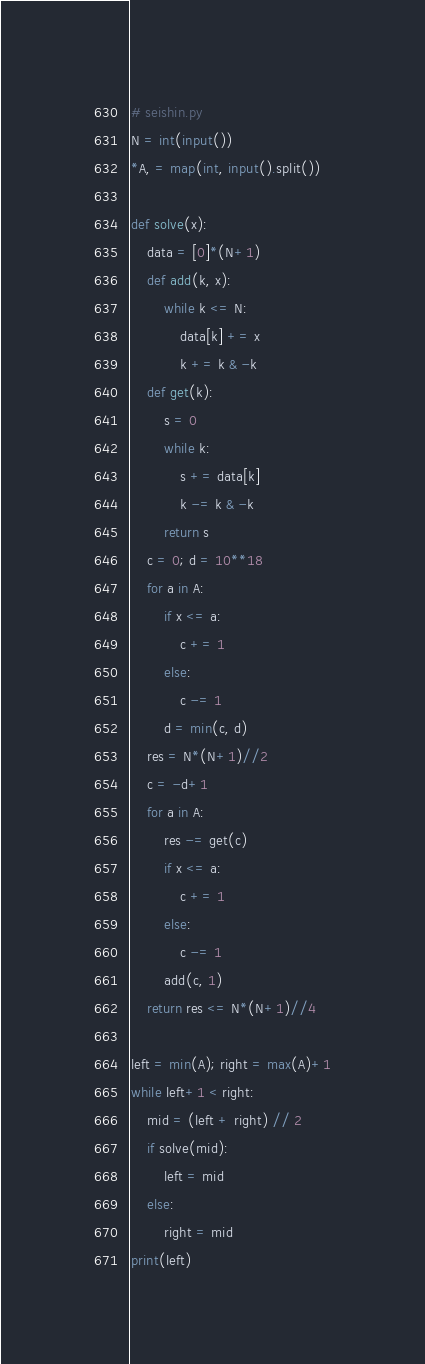Convert code to text. <code><loc_0><loc_0><loc_500><loc_500><_Python_># seishin.py
N = int(input())
*A, = map(int, input().split())

def solve(x):
    data = [0]*(N+1)
    def add(k, x):
        while k <= N:
            data[k] += x
            k += k & -k
    def get(k):
        s = 0
        while k:
            s += data[k]
            k -= k & -k
        return s
    c = 0; d = 10**18
    for a in A:
        if x <= a:
            c += 1
        else:
            c -= 1
        d = min(c, d)
    res = N*(N+1)//2
    c = -d+1
    for a in A:
        res -= get(c)
        if x <= a:
            c += 1
        else:
            c -= 1
        add(c, 1)
    return res <= N*(N+1)//4

left = min(A); right = max(A)+1
while left+1 < right:
    mid = (left + right) // 2
    if solve(mid):
        left = mid
    else:
        right = mid
print(left)</code> 